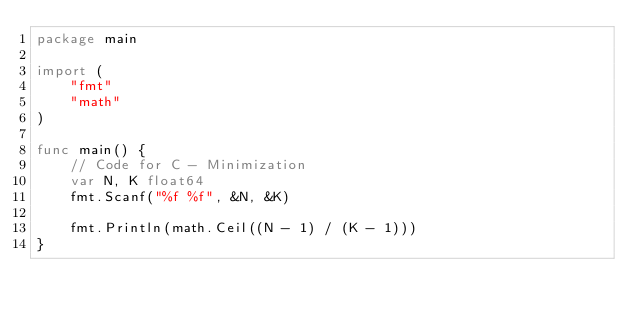<code> <loc_0><loc_0><loc_500><loc_500><_Go_>package main

import (
	"fmt"
	"math"
)

func main() {
	// Code for C - Minimization
	var N, K float64
	fmt.Scanf("%f %f", &N, &K)

	fmt.Println(math.Ceil((N - 1) / (K - 1)))
}
</code> 